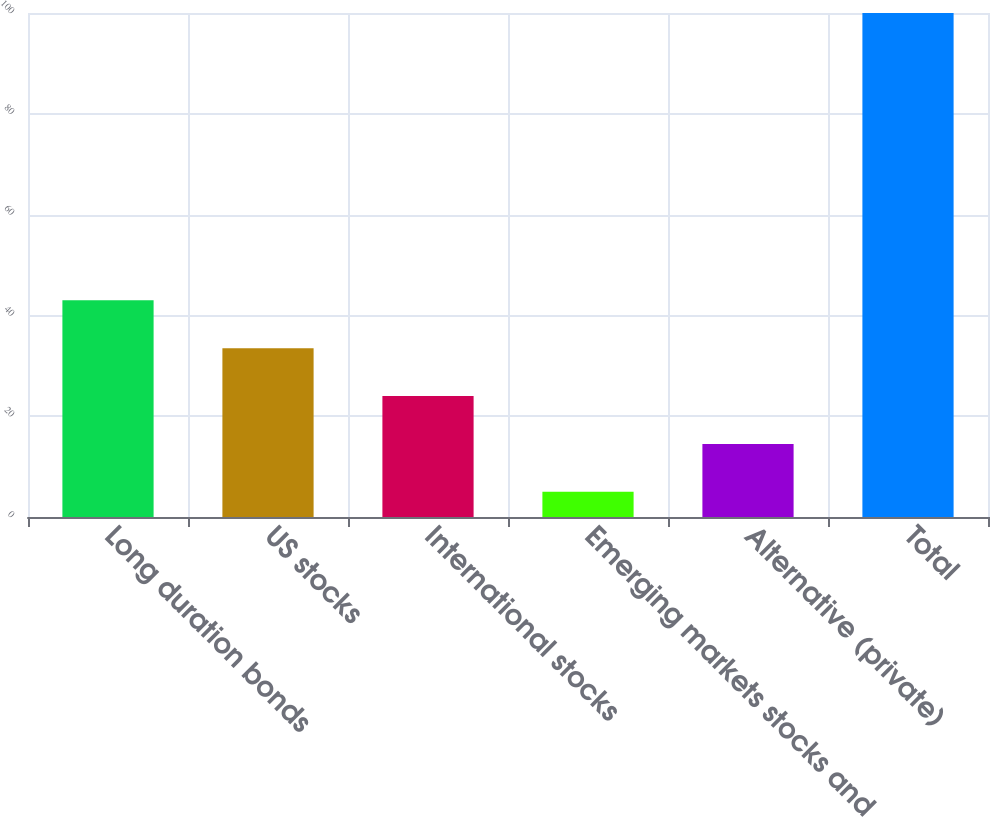Convert chart. <chart><loc_0><loc_0><loc_500><loc_500><bar_chart><fcel>Long duration bonds<fcel>US stocks<fcel>International stocks<fcel>Emerging markets stocks and<fcel>Alternative (private)<fcel>Total<nl><fcel>43<fcel>33.5<fcel>24<fcel>5<fcel>14.5<fcel>100<nl></chart> 